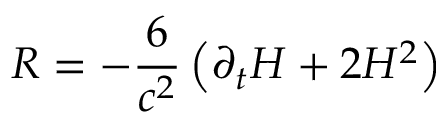<formula> <loc_0><loc_0><loc_500><loc_500>R = - \frac { 6 } { c ^ { 2 } } \left ( \partial _ { t } H + 2 H ^ { 2 } \right )</formula> 